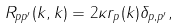<formula> <loc_0><loc_0><loc_500><loc_500>R _ { p p ^ { \prime } } ( { k } , { k } ) = 2 \kappa r _ { p } ( { k } ) \delta _ { p , p ^ { \prime } } ,</formula> 